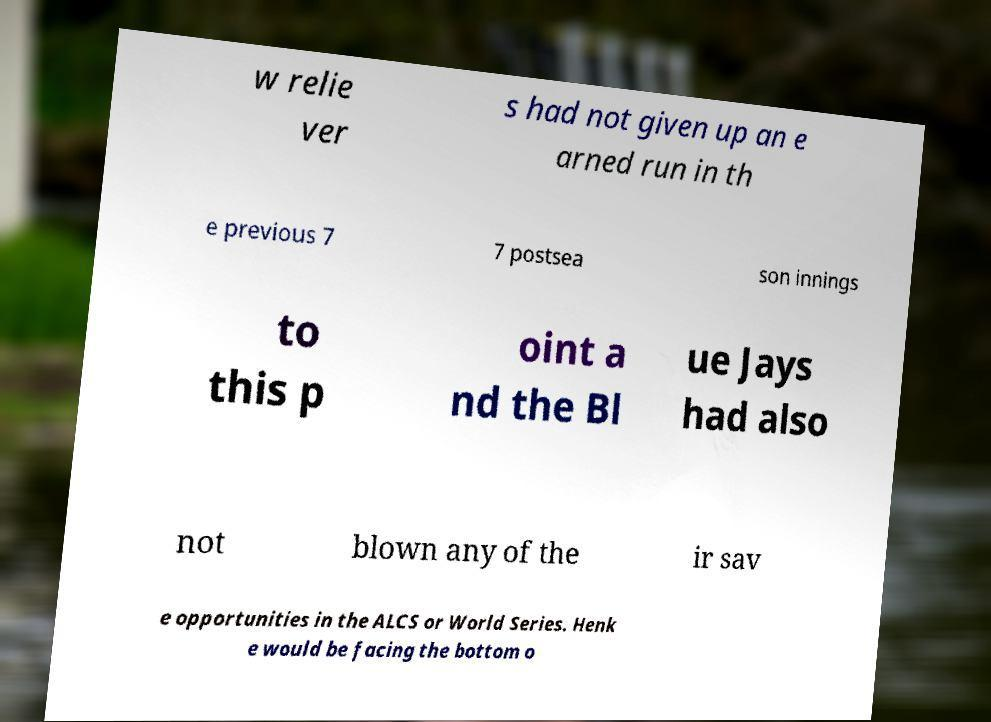What messages or text are displayed in this image? I need them in a readable, typed format. w relie ver s had not given up an e arned run in th e previous 7 7 postsea son innings to this p oint a nd the Bl ue Jays had also not blown any of the ir sav e opportunities in the ALCS or World Series. Henk e would be facing the bottom o 